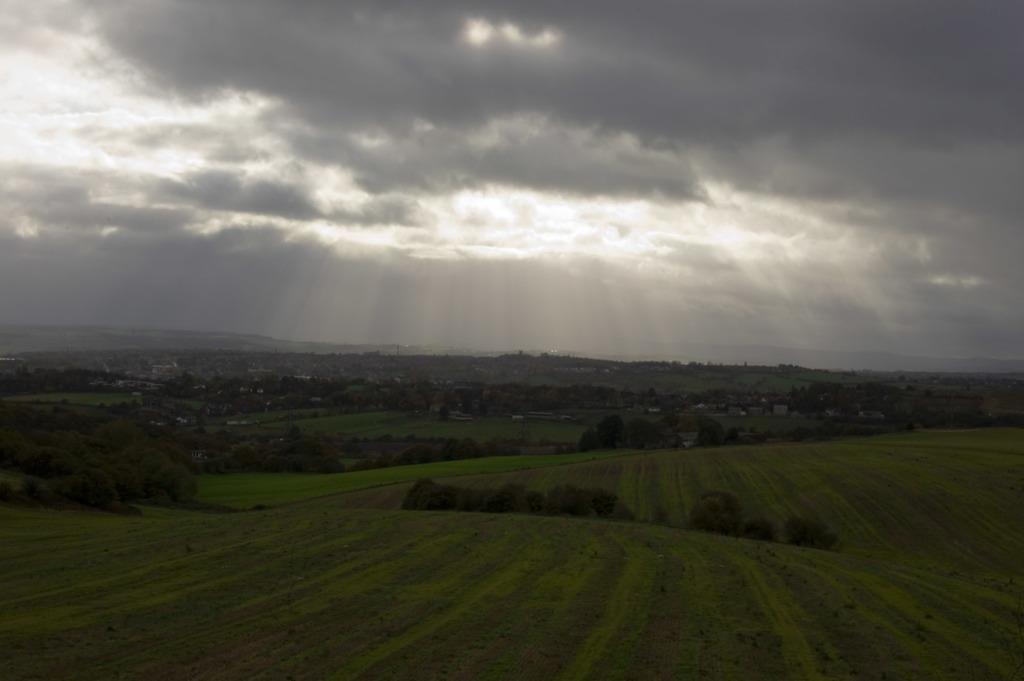Describe this image in one or two sentences. In this image we can see grass on the ground. Also there are trees. In the background there is sky with clouds. 